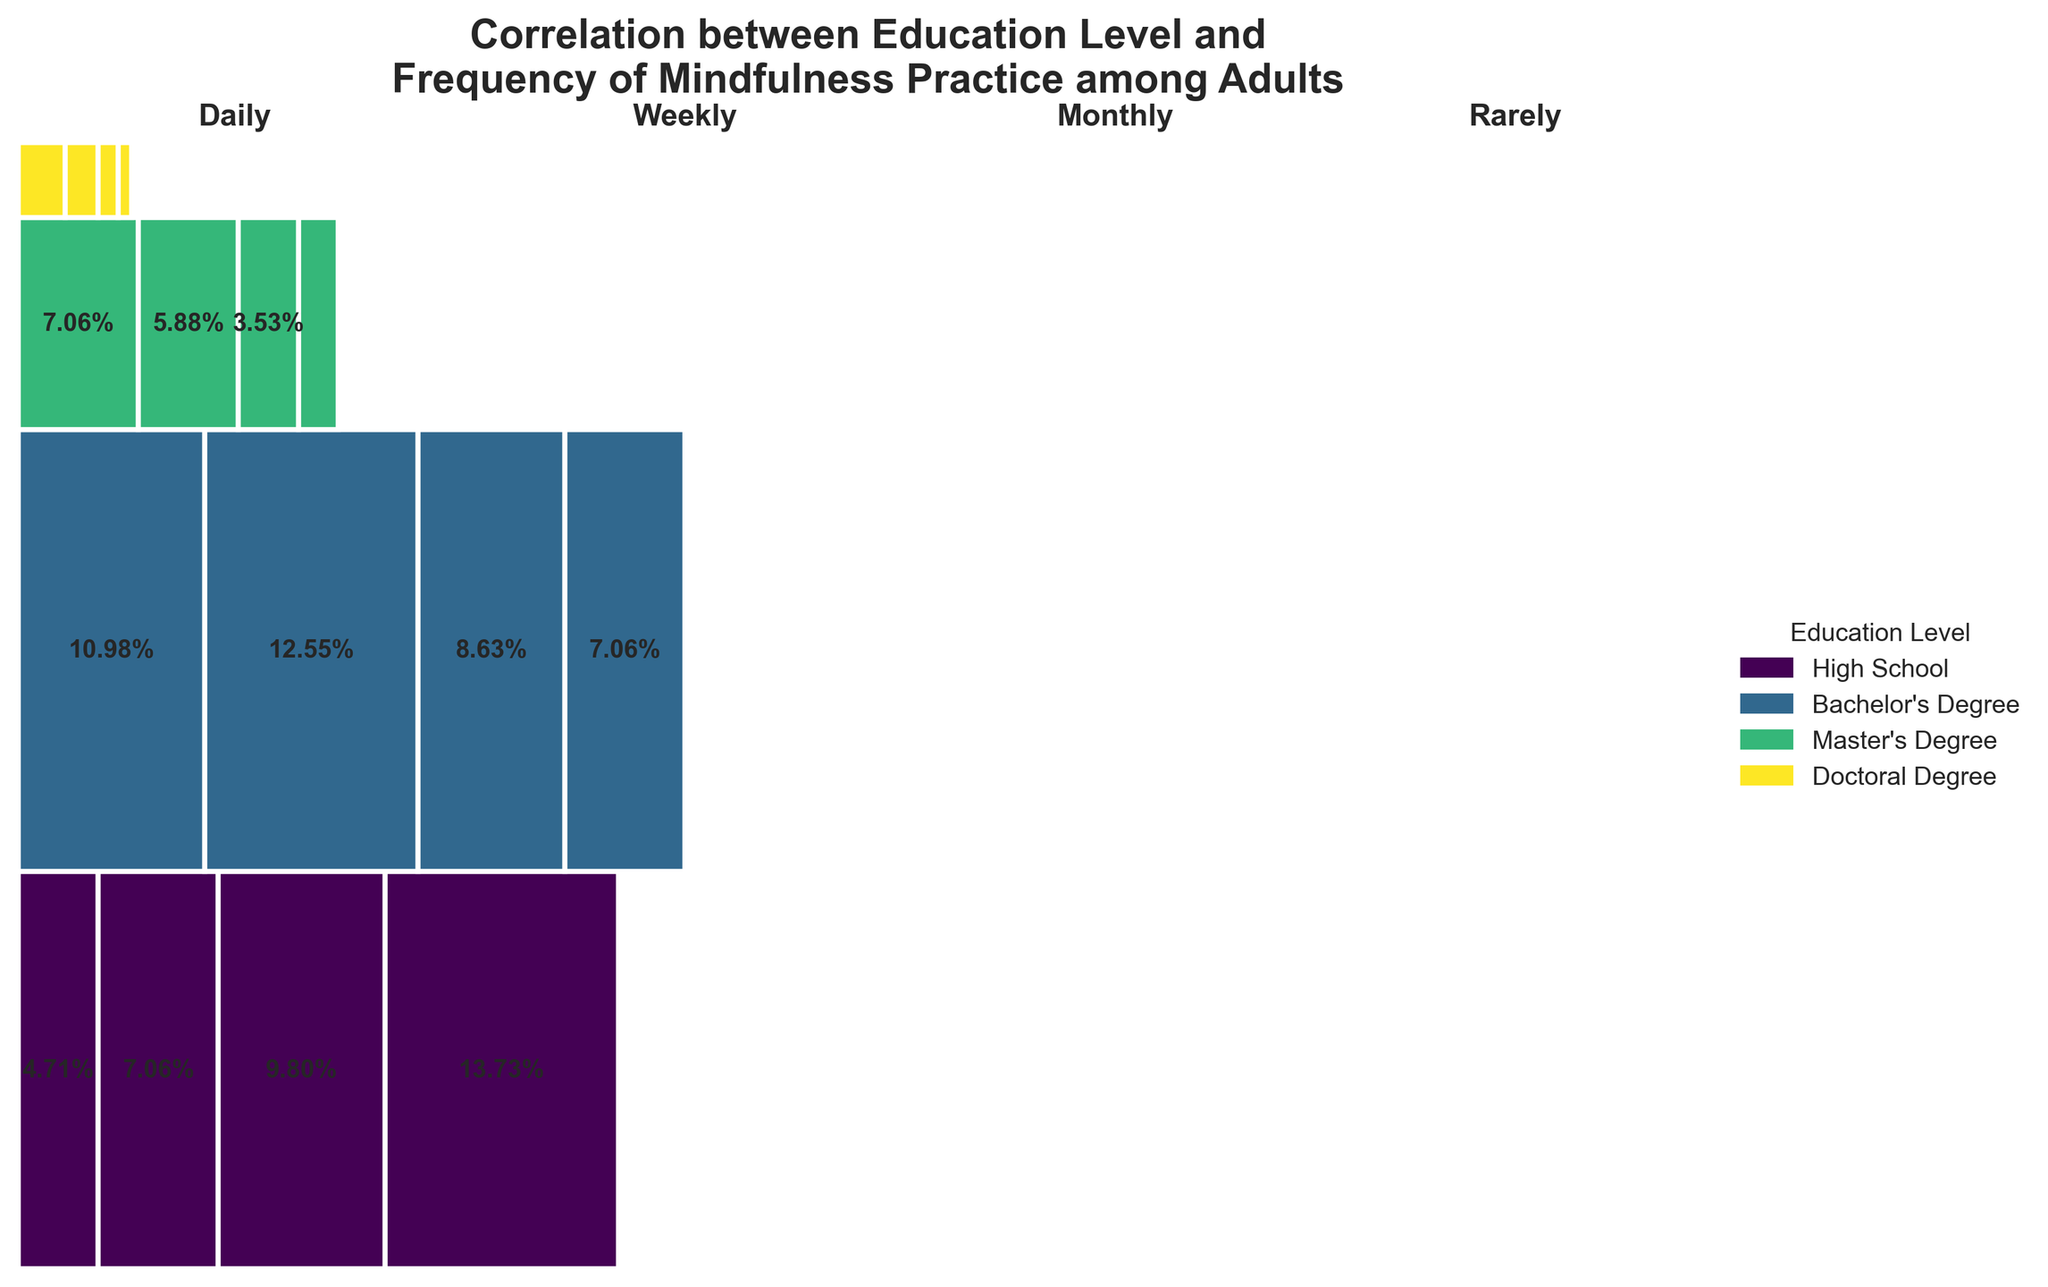What is the title of the plot? Look at the top of the figure to find the title. It reads "Correlation between Education Level and Frequency of Mindfulness Practice among Adults."
Answer: Correlation between Education Level and Frequency of Mindfulness Practice among Adults Which frequency of mindfulness practice has the highest proportion among individuals with a high school education? Locate the section for High School education and observe the rectangles for various frequencies. The largest rectangle corresponds to "Rarely."
Answer: Rarely How does the frequency of daily mindfulness practice compare between those with a Master's degree and a Doctoral degree? Look at the "Daily" sections for both Master's and Doctoral degrees. The area for Master's degree is larger than that for Doctoral degree, indicating a higher count and proportion for Master's.
Answer: Higher for Master's Degree What is the proportion of individuals with a Bachelor's degree who practice mindfulness monthly? Look at the "Monthly" section within the Bachelor's degree category and read the proportion indicated inside the rectangle. This proportion is shown as a percentage in the figure.
Answer: About 4.4% What are the proportions of individuals who rarely practice mindfulness across different education levels? Identify the "Rarely" sections for all education levels, adding the given proportions inside each rectangle for visual clarity. Add these to verify the accuracy of each proportion segment.
Answer: High School: about 6.67%, Bachelor's Degree: about 3.43%, Master's Degree: about 1.14%, Doctoral Degree: about 0.38% What is the most common frequency of mindfulness practice among those with a Bachelor's degree? Examine the largest rectangle in the Bachelor's degree category, which corresponds to "Weekly."
Answer: Weekly What is the total proportion of individuals practicing mindfulness, either daily or weekly, across all education levels? Sum the proportions for "Daily" and "Weekly" across all educational categories: Daily (High School: ~2.29%, Bachelor's: ~5.33%, Master's: ~3.43%, Doctoral: ~1.33%) and Weekly (High School: ~3.43%, Bachelor's: ~6.10%, Master's: ~2.86%, Doctoral: ~0.95%). The total is the sum of these values.
Answer: About 25.2% Among the different levels of education, which has the smallest proportion of individuals practicing mindfulness daily? Compare the "Daily" sections across all education levels and find that the Doctoral Degree has the smallest segment.
Answer: Doctoral Degree What is the combined proportion of individuals with a Master's degree who practice mindfulness monthly or rarely? Locate the "Monthly" and "Rarely" sections for the Master's degree category and add their proportions together: Monthly: ~1.43%, Rarely: ~0.95%.
Answer: About 2.38% 